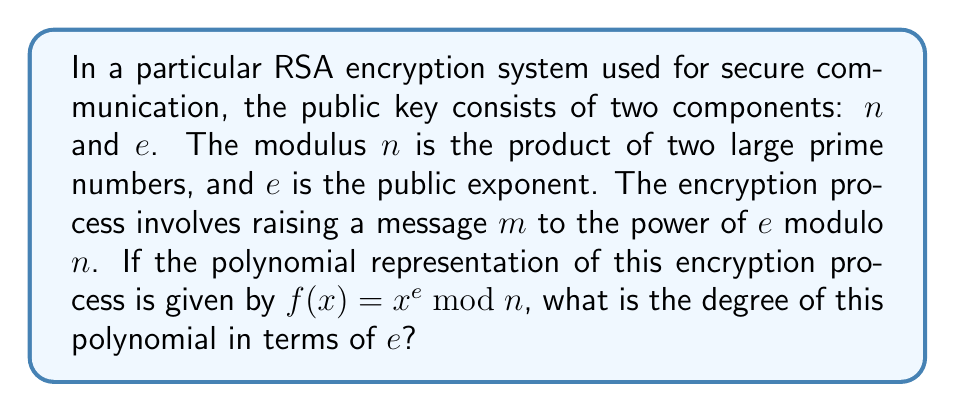What is the answer to this math problem? To determine the degree of the polynomial used in this RSA encryption process, we need to consider the following steps:

1) The encryption function is represented as $f(x) = x^e \bmod n$

2) In polynomial arithmetic, the degree of a polynomial is the highest power of the variable. In this case, the variable is $x$.

3) The exponent $e$ determines the highest power of $x$ in the polynomial before the modulo operation is applied.

4) The modulo operation $\bmod n$ doesn't change the degree of the polynomial. It only affects the coefficients and the range of possible values, but not the highest power of $x$.

5) Therefore, the degree of the polynomial $f(x) = x^e \bmod n$ is equal to $e$.

It's worth noting that in practical RSA implementations, $e$ is typically chosen to be a small odd integer (often 65537) for efficiency reasons, while maintaining a high level of security. However, regardless of the specific value of $e$, it always determines the degree of the encryption polynomial.

This understanding of polynomial degree in cryptographic algorithms is crucial for cybersecurity specialists, as it relates to the computational complexity and security strength of the encryption process.
Answer: The degree of the polynomial $f(x) = x^e \bmod n$ used in this RSA encryption process is $e$. 